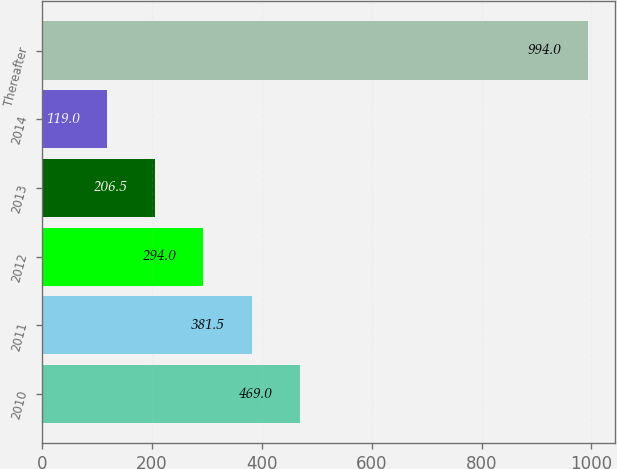<chart> <loc_0><loc_0><loc_500><loc_500><bar_chart><fcel>2010<fcel>2011<fcel>2012<fcel>2013<fcel>2014<fcel>Thereafter<nl><fcel>469<fcel>381.5<fcel>294<fcel>206.5<fcel>119<fcel>994<nl></chart> 